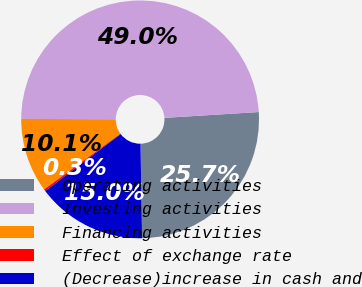<chart> <loc_0><loc_0><loc_500><loc_500><pie_chart><fcel>Operating activities<fcel>Investing activities<fcel>Financing activities<fcel>Effect of exchange rate<fcel>(Decrease)increase in cash and<nl><fcel>25.72%<fcel>48.96%<fcel>10.1%<fcel>0.26%<fcel>14.97%<nl></chart> 